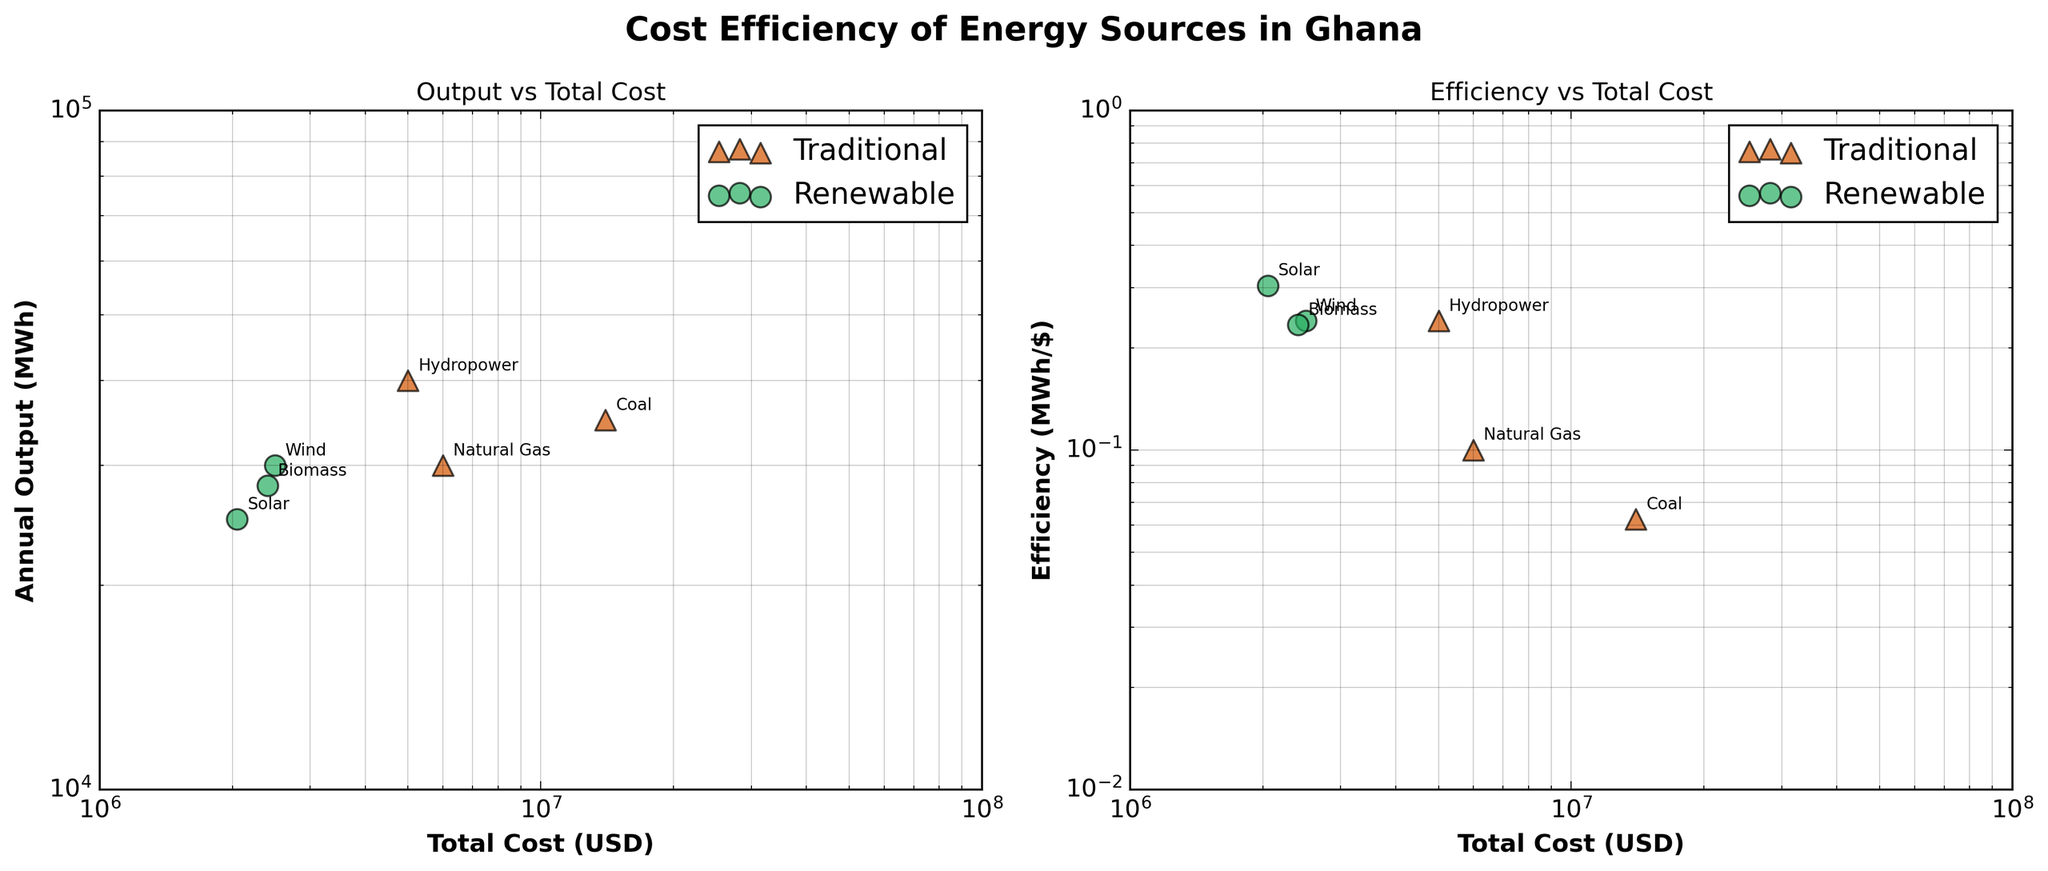What's the title of the figure? The title of the figure is displayed at the top and can be read directly.
Answer: Cost Efficiency of Energy Sources in Ghana How many types of energy sources are shown in the figure? By looking at the legends and data points in the plots, we can see there are two categories: Traditional and Renewable.
Answer: Two Which energy source has the highest total cost in the figure? On the x-axis (Total Cost), the Hydropower data point is the furthest right, indicating the highest cost.
Answer: Hydropower Among renewable sources, which one has the highest efficiency? Looking at the second subplot (Efficiency vs Total Cost), the Solar data point is the highest on the y-axis among renewable sources.
Answer: Solar What is the relationship between Total Cost and Annual Output for Traditional sources? By analyzing the first subplot (Output vs Total Cost) and the data distribution, we observe that as total cost increases from Natural Gas to Coal to Hydropower, the Annual Output also increases.
Answer: Positive correlation Which energy source has the lowest efficiency? From the second subplot (Efficiency vs Total Cost), the Biomass data point is the lowest on the y-axis.
Answer: Biomass If we compare total costs, which renewable source is closest to Hydropower in terms of total cost? By examining the x-axis in the first subplot, the Wind data point is closest to Hydropower in terms of total cost.
Answer: Wind What color is used to represent Traditional energy sources? The legend and data points of traditional sources are consistently in a specific color.
Answer: Orange What marker shape is used for Renewable energy sources? Looking at the markers in the plot and comparing them with the legend, Renewable sources use a circular marker.
Answer: Circle (o) What scale is used for the axes in both subplots? Observing the ticks and labels on the axes in both subplots, they follow a specific exponential pattern, indicating they are in logarithmic scale.
Answer: Log scale What is the total lifetime output of the Coal energy source? Lifetime output can be calculated as Annual Output multiplied by Lifetime. For Coal, it is 35000 MWh/year * 25 years = 875000 MWh.
Answer: 875000 MWh 